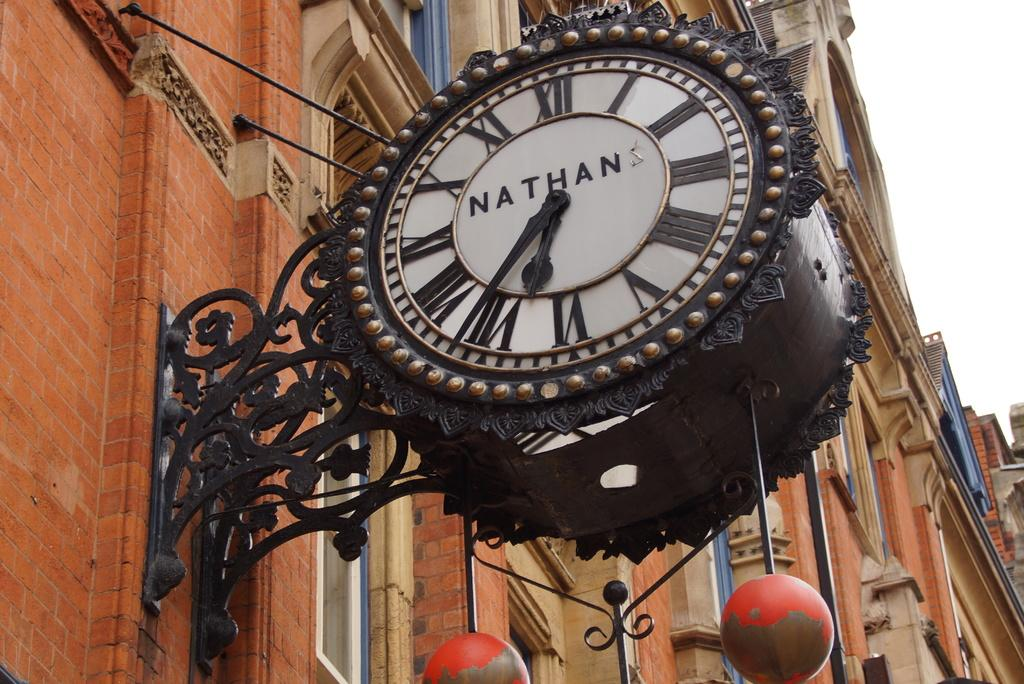<image>
Describe the image concisely. Clock hanging on a building that says NATHAN on it. 